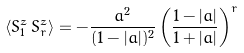Convert formula to latex. <formula><loc_0><loc_0><loc_500><loc_500>\left \langle S _ { 1 } ^ { z } \, S _ { r } ^ { z } \right \rangle = - \frac { a ^ { 2 } } { ( 1 - | a | ) ^ { 2 } } \left ( \frac { 1 - | a | } { 1 + | a | } \right ) ^ { r }</formula> 